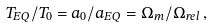Convert formula to latex. <formula><loc_0><loc_0><loc_500><loc_500>T _ { E Q } / T _ { 0 } = a _ { 0 } / a _ { E Q } = \Omega _ { m } / \Omega _ { r e l } \, ,</formula> 